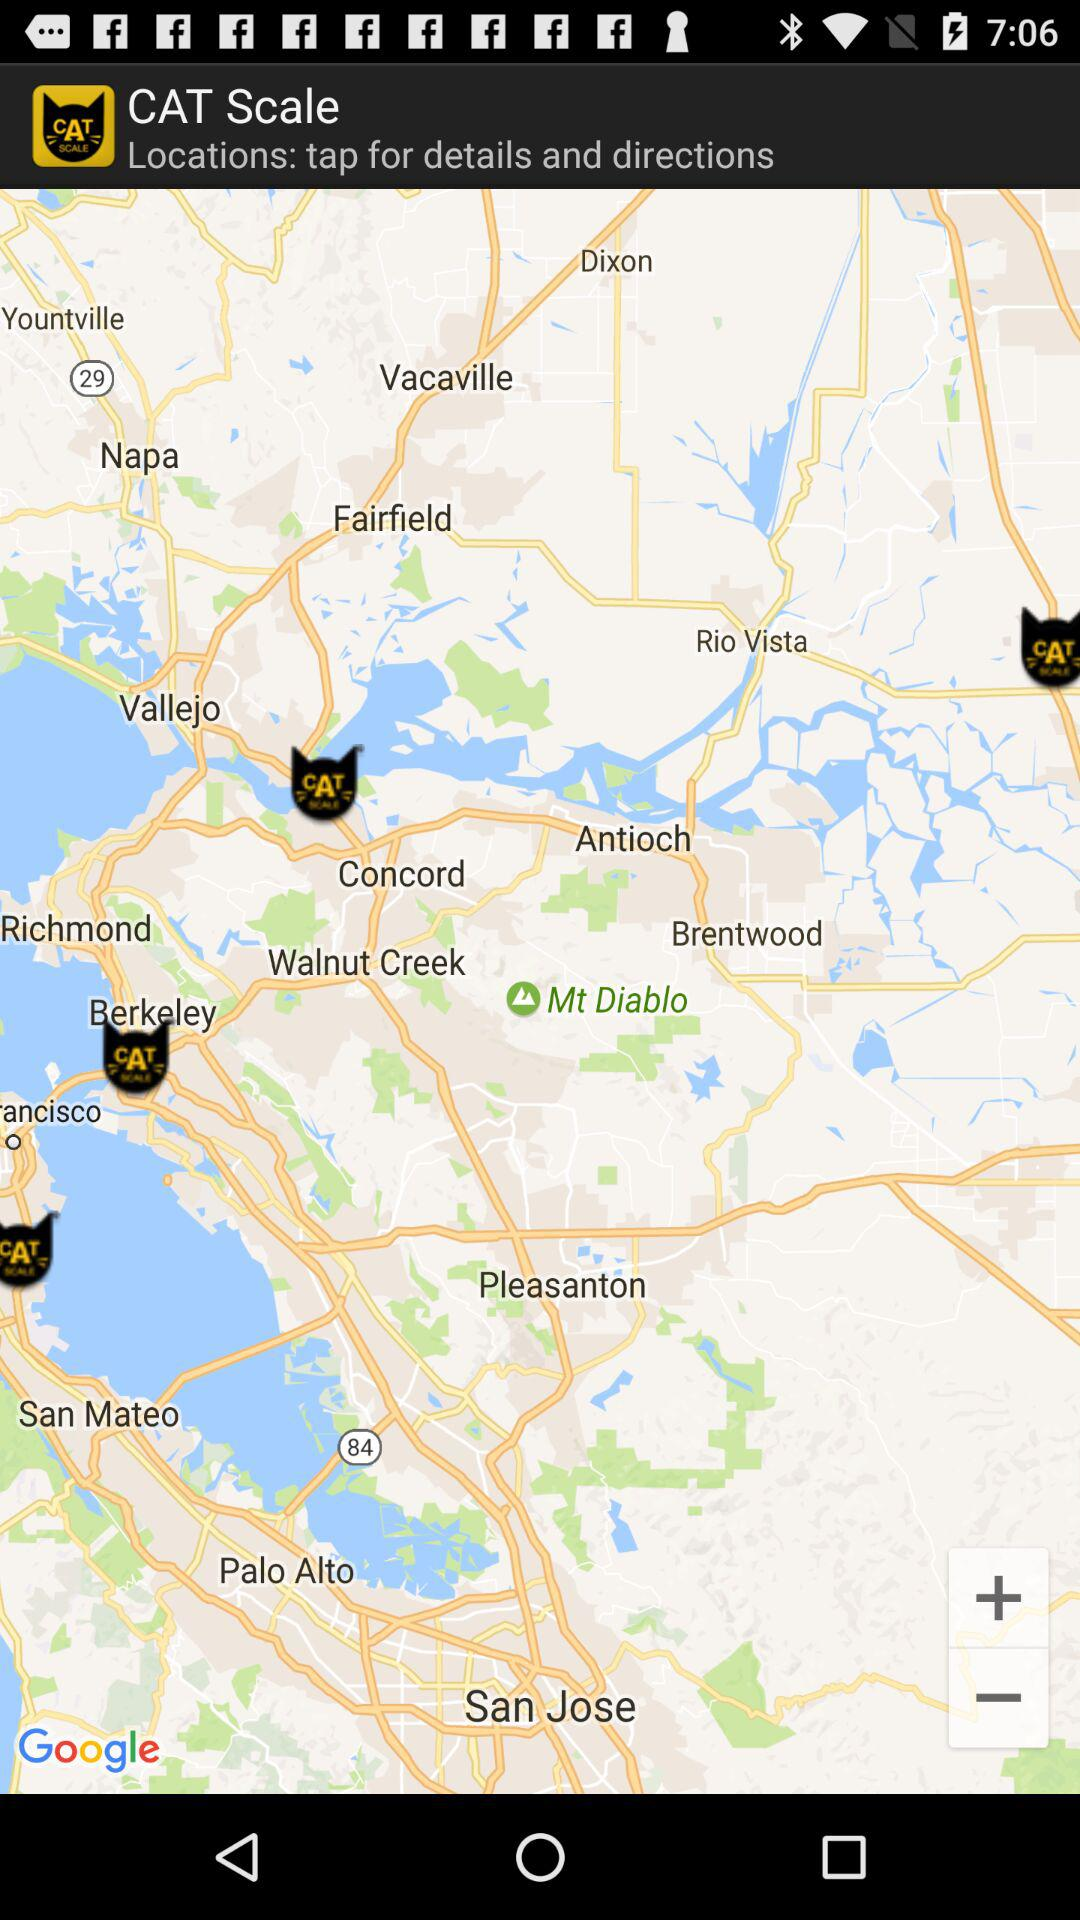What is the city name? The city name is San Francisco. 